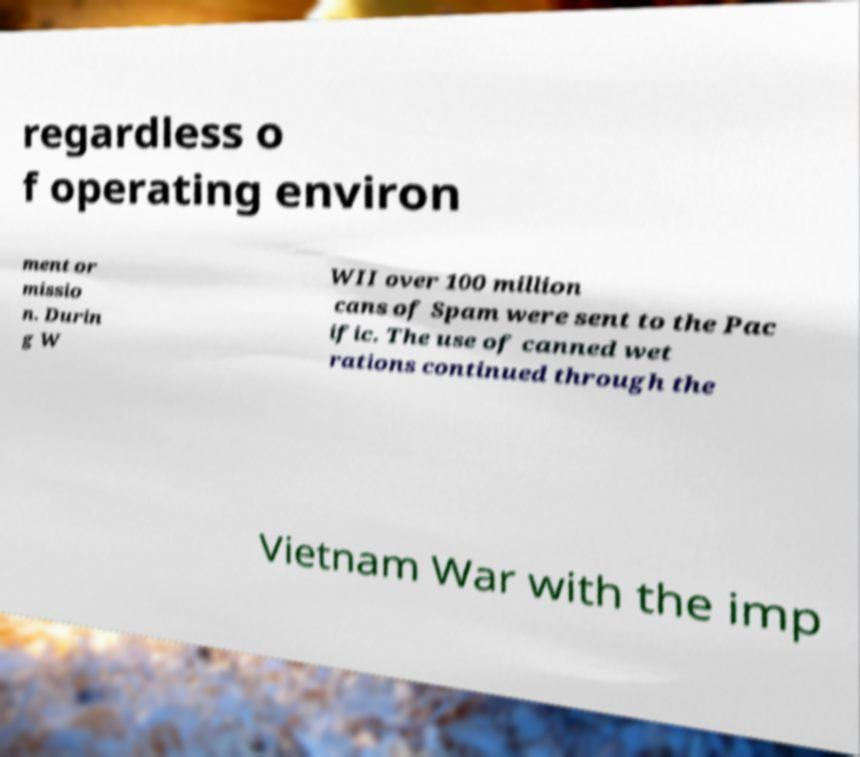Could you assist in decoding the text presented in this image and type it out clearly? regardless o f operating environ ment or missio n. Durin g W WII over 100 million cans of Spam were sent to the Pac ific. The use of canned wet rations continued through the Vietnam War with the imp 